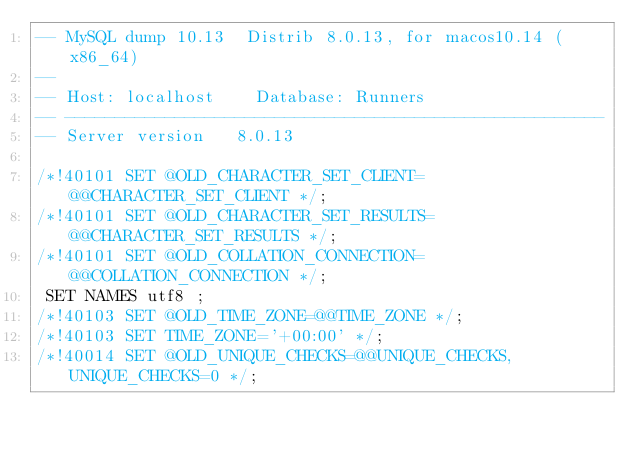<code> <loc_0><loc_0><loc_500><loc_500><_SQL_>-- MySQL dump 10.13  Distrib 8.0.13, for macos10.14 (x86_64)
--
-- Host: localhost    Database: Runners
-- ------------------------------------------------------
-- Server version	8.0.13

/*!40101 SET @OLD_CHARACTER_SET_CLIENT=@@CHARACTER_SET_CLIENT */;
/*!40101 SET @OLD_CHARACTER_SET_RESULTS=@@CHARACTER_SET_RESULTS */;
/*!40101 SET @OLD_COLLATION_CONNECTION=@@COLLATION_CONNECTION */;
 SET NAMES utf8 ;
/*!40103 SET @OLD_TIME_ZONE=@@TIME_ZONE */;
/*!40103 SET TIME_ZONE='+00:00' */;
/*!40014 SET @OLD_UNIQUE_CHECKS=@@UNIQUE_CHECKS, UNIQUE_CHECKS=0 */;</code> 